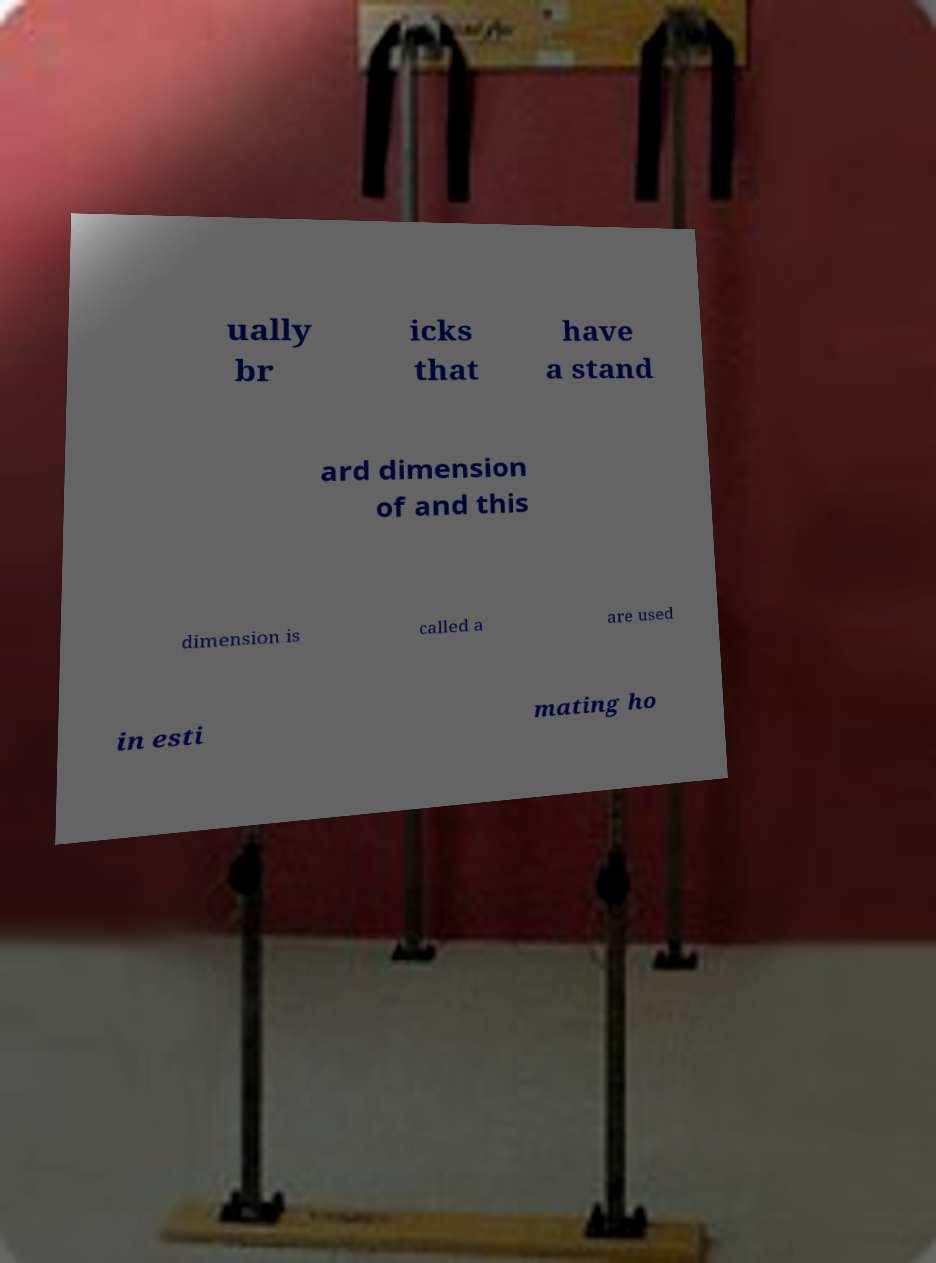Can you read and provide the text displayed in the image?This photo seems to have some interesting text. Can you extract and type it out for me? ually br icks that have a stand ard dimension of and this dimension is called a are used in esti mating ho 